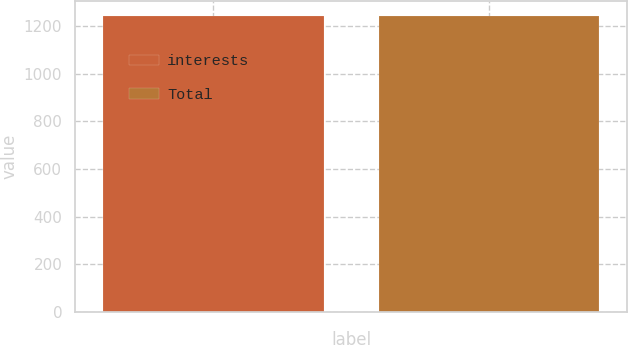Convert chart to OTSL. <chart><loc_0><loc_0><loc_500><loc_500><bar_chart><fcel>interests<fcel>Total<nl><fcel>1245<fcel>1245.1<nl></chart> 